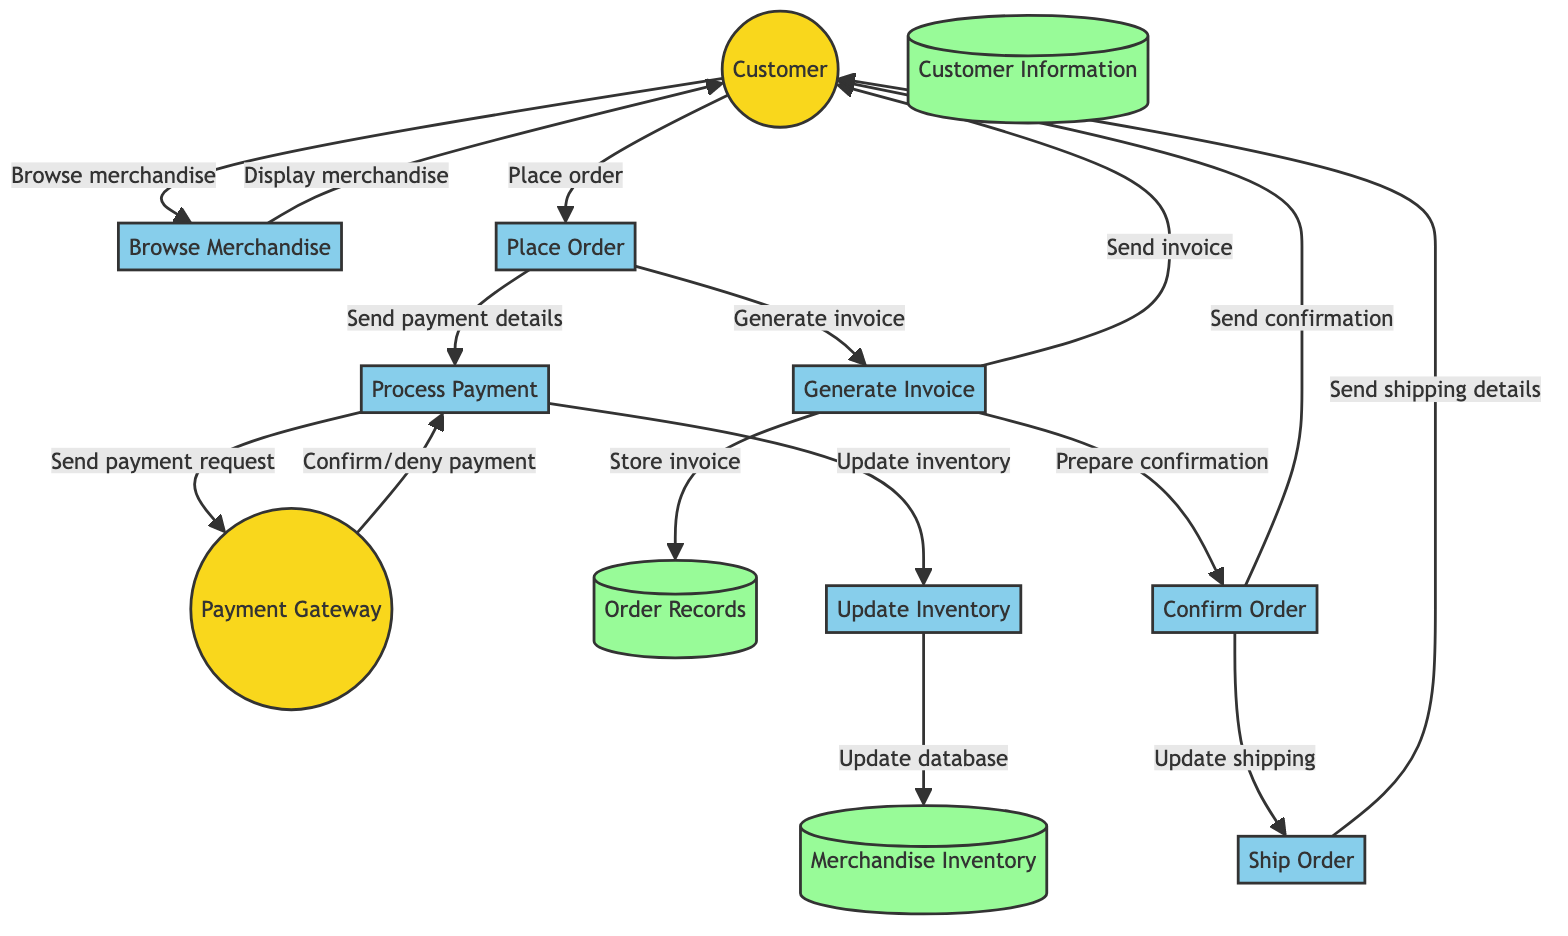What is the first process the customer engages in? The diagram shows that the first process initiated by the customer is "Browse Merchandise." This is the starting point for the customer to look at available merchandise before making a purchase.
Answer: Browse Merchandise How many external entities are present in the diagram? There are two external entities shown in the diagram: "Customer" and "Payment Gateway." These entities represent outside systems or users interacting with the processes.
Answer: 2 Which process is responsible for sending payment requests? The process responsible for sending payment requests is "Process Payment." This step includes the action of relaying payment information to the payment gateway after the customer places an order.
Answer: Process Payment What does the "Generate Invoice" process send to the customer? The "Generate Invoice" process sends the invoice to the customer. This communication is part of the order confirmation and finalizes the transaction details.
Answer: Invoice What happens after the "Process Payment" is confirmed? Once the "Process Payment" is confirmed by the payment gateway, the next step is "Update Inventory." This ensures that the inventory reflects the successful transaction.
Answer: Update Inventory How many data stores are included in the diagram? The diagram contains three data stores: "Merchandise Inventory," "Order Records," and "Customer Information." These stores hold crucial information related to the merchandise, orders, and customers.
Answer: 3 What is the last process in the flow after the order is confirmed? The last process is "Ship Order," which involves preparing the order for dispatch and sending shipping details to the customer after confirmation.
Answer: Ship Order Which entity does the system send the order confirmation to? The system sends the order confirmation to the "Customer." This ensures that the customer is notified about the status of their order following the transaction.
Answer: Customer What data store is updated when the inventory is modified? The data store that is updated is "Merchandise Inventory." The inventory tracks the available merchandise and gets updated to reflect any changes resulting from orders placed.
Answer: Merchandise Inventory 